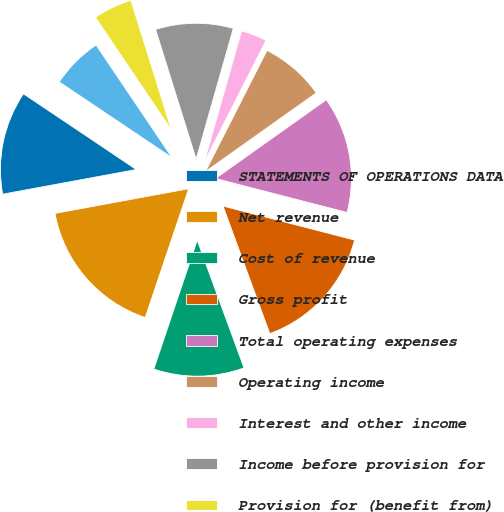Convert chart to OTSL. <chart><loc_0><loc_0><loc_500><loc_500><pie_chart><fcel>STATEMENTS OF OPERATIONS DATA<fcel>Net revenue<fcel>Cost of revenue<fcel>Gross profit<fcel>Total operating expenses<fcel>Operating income<fcel>Interest and other income<fcel>Income before provision for<fcel>Provision for (benefit from)<fcel>Net income<nl><fcel>12.31%<fcel>16.92%<fcel>10.77%<fcel>15.38%<fcel>13.85%<fcel>7.69%<fcel>3.08%<fcel>9.23%<fcel>4.62%<fcel>6.15%<nl></chart> 